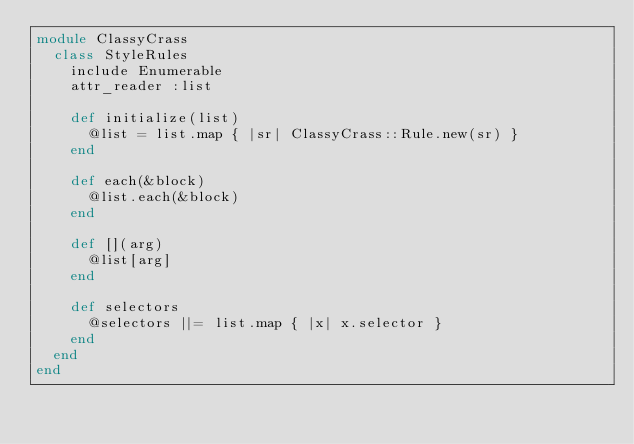<code> <loc_0><loc_0><loc_500><loc_500><_Ruby_>module ClassyCrass
  class StyleRules
    include Enumerable
    attr_reader :list

    def initialize(list)
      @list = list.map { |sr| ClassyCrass::Rule.new(sr) }
    end

    def each(&block)
      @list.each(&block)
    end

    def [](arg)
      @list[arg]
    end

    def selectors
      @selectors ||= list.map { |x| x.selector }
    end
  end
end
</code> 